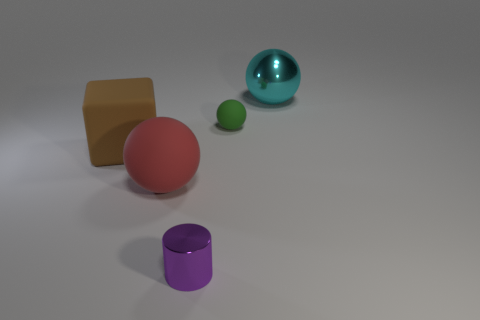Are the cyan object and the block made of the same material?
Provide a succinct answer. No. Is the number of purple metallic objects greater than the number of large gray rubber things?
Your response must be concise. Yes. Does the tiny cylinder have the same color as the ball behind the green ball?
Give a very brief answer. No. What is the color of the object that is both in front of the big brown object and behind the purple cylinder?
Your response must be concise. Red. What number of other things are there of the same material as the large red sphere
Your answer should be compact. 2. Is the number of big blocks less than the number of big objects?
Give a very brief answer. Yes. Are the tiny cylinder and the big sphere that is in front of the cyan sphere made of the same material?
Your answer should be very brief. No. What shape is the metal object in front of the cyan shiny sphere?
Give a very brief answer. Cylinder. Is the number of rubber objects to the right of the green matte sphere less than the number of big blue metal objects?
Ensure brevity in your answer.  No. What number of red things are the same size as the purple metal object?
Provide a succinct answer. 0. 